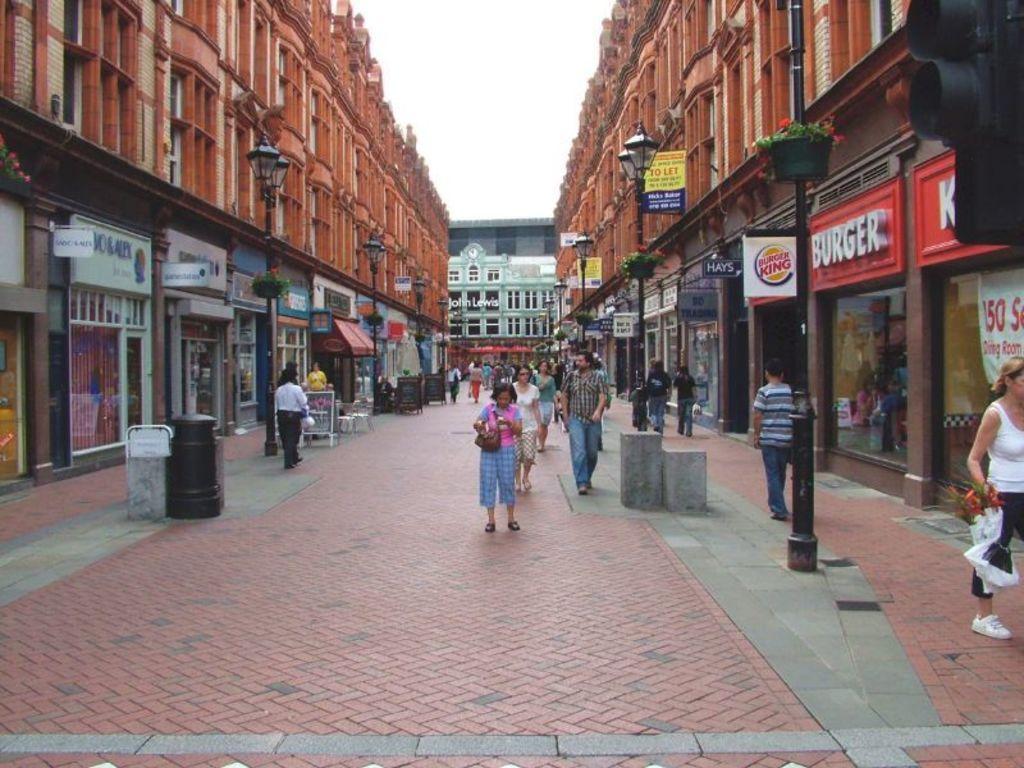Describe this image in one or two sentences. In the center of the image we can see some people are walking on the pavement and a lady is carrying a bag. In the background of the image we can see the buildings, windows, poles, lights, boards and some people are walking and some of them are standing. At the bottom of the image we can see the pavement. At the top of the image we can see the sky. 